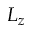<formula> <loc_0><loc_0><loc_500><loc_500>L _ { z }</formula> 